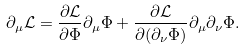<formula> <loc_0><loc_0><loc_500><loc_500>\partial _ { \mu } { \mathcal { L } } = \frac { \partial { \mathcal { L } } } { \partial \Phi } \partial _ { \mu } \Phi + \frac { \partial { \mathcal { L } } } { \partial ( \partial _ { \nu } \Phi ) } \partial _ { \mu } \partial _ { \nu } \Phi .</formula> 